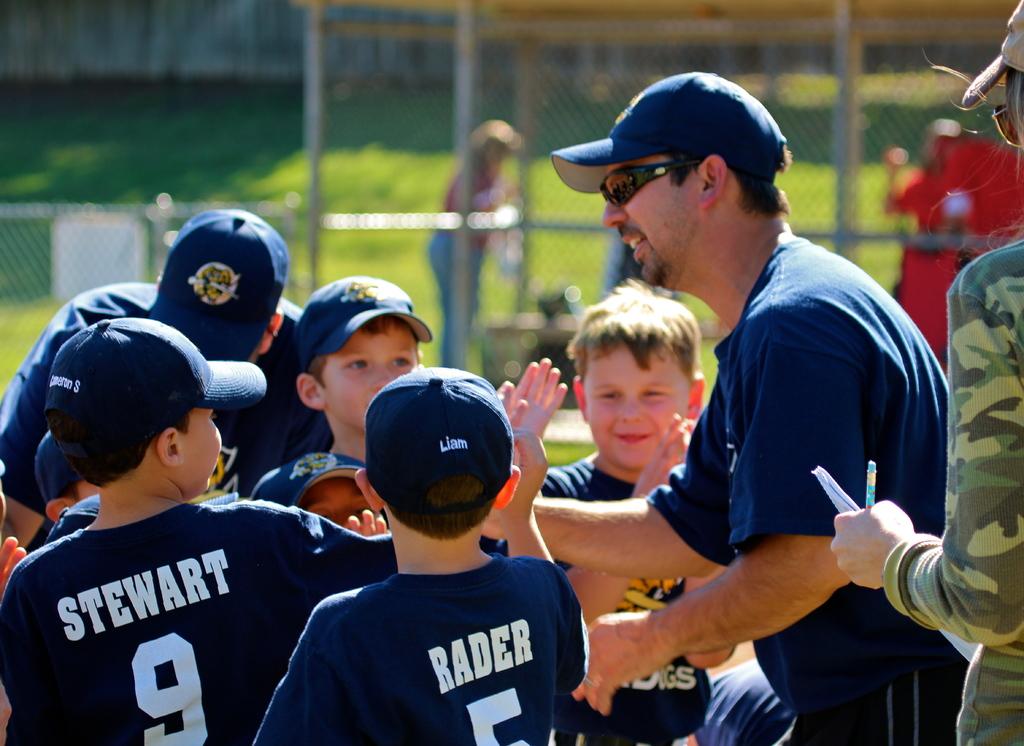Who is player number 9?
Make the answer very short. Stewart. 